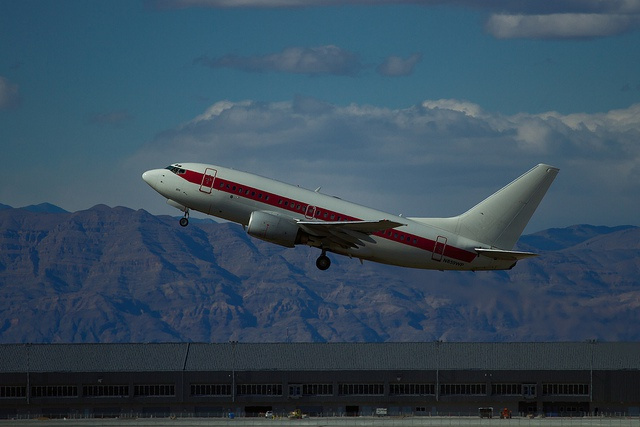Describe the objects in this image and their specific colors. I can see airplane in blue, black, gray, darkgray, and maroon tones and truck in blue, black, gray, and darkgreen tones in this image. 